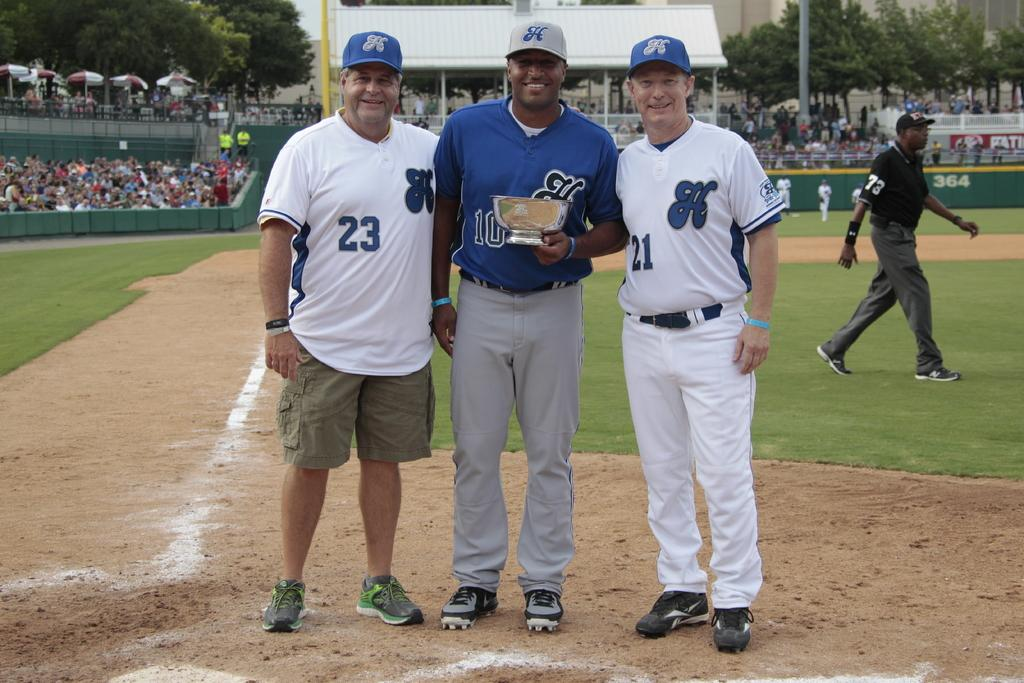<image>
Summarize the visual content of the image. A player wearing the number 21 stands next to a man in a blue jersey 